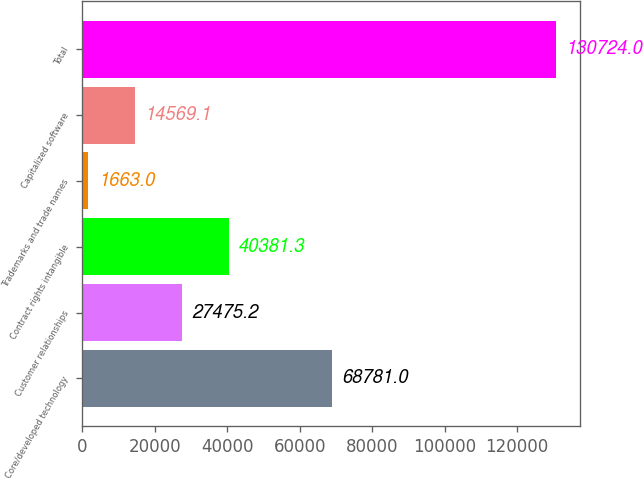Convert chart. <chart><loc_0><loc_0><loc_500><loc_500><bar_chart><fcel>Core/developed technology<fcel>Customer relationships<fcel>Contract rights intangible<fcel>Trademarks and trade names<fcel>Capitalized software<fcel>Total<nl><fcel>68781<fcel>27475.2<fcel>40381.3<fcel>1663<fcel>14569.1<fcel>130724<nl></chart> 